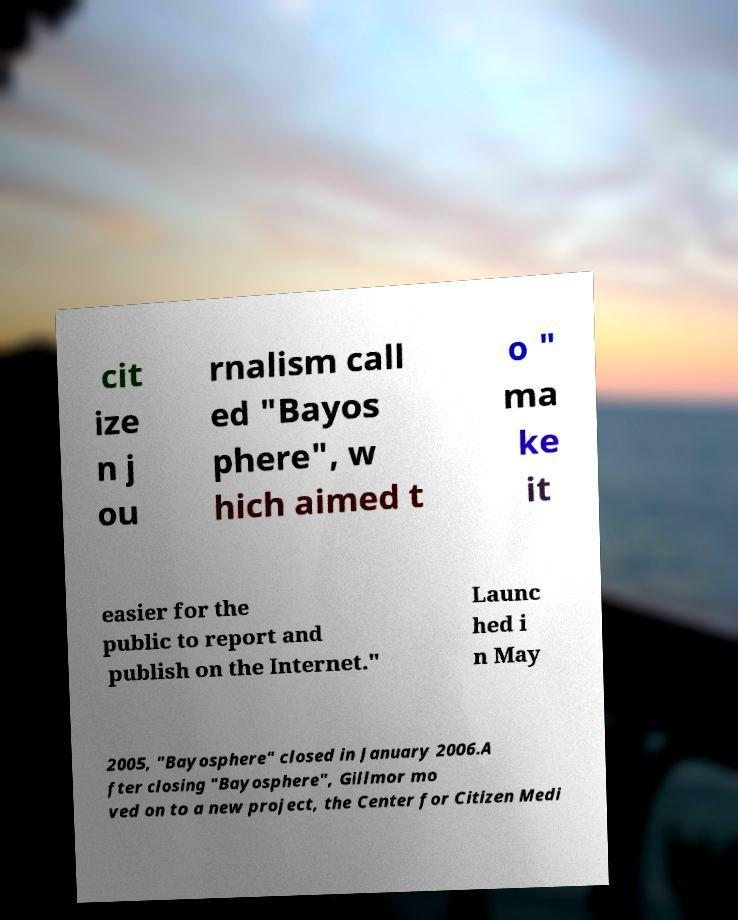Can you read and provide the text displayed in the image?This photo seems to have some interesting text. Can you extract and type it out for me? cit ize n j ou rnalism call ed "Bayos phere", w hich aimed t o " ma ke it easier for the public to report and publish on the Internet." Launc hed i n May 2005, "Bayosphere" closed in January 2006.A fter closing "Bayosphere", Gillmor mo ved on to a new project, the Center for Citizen Medi 